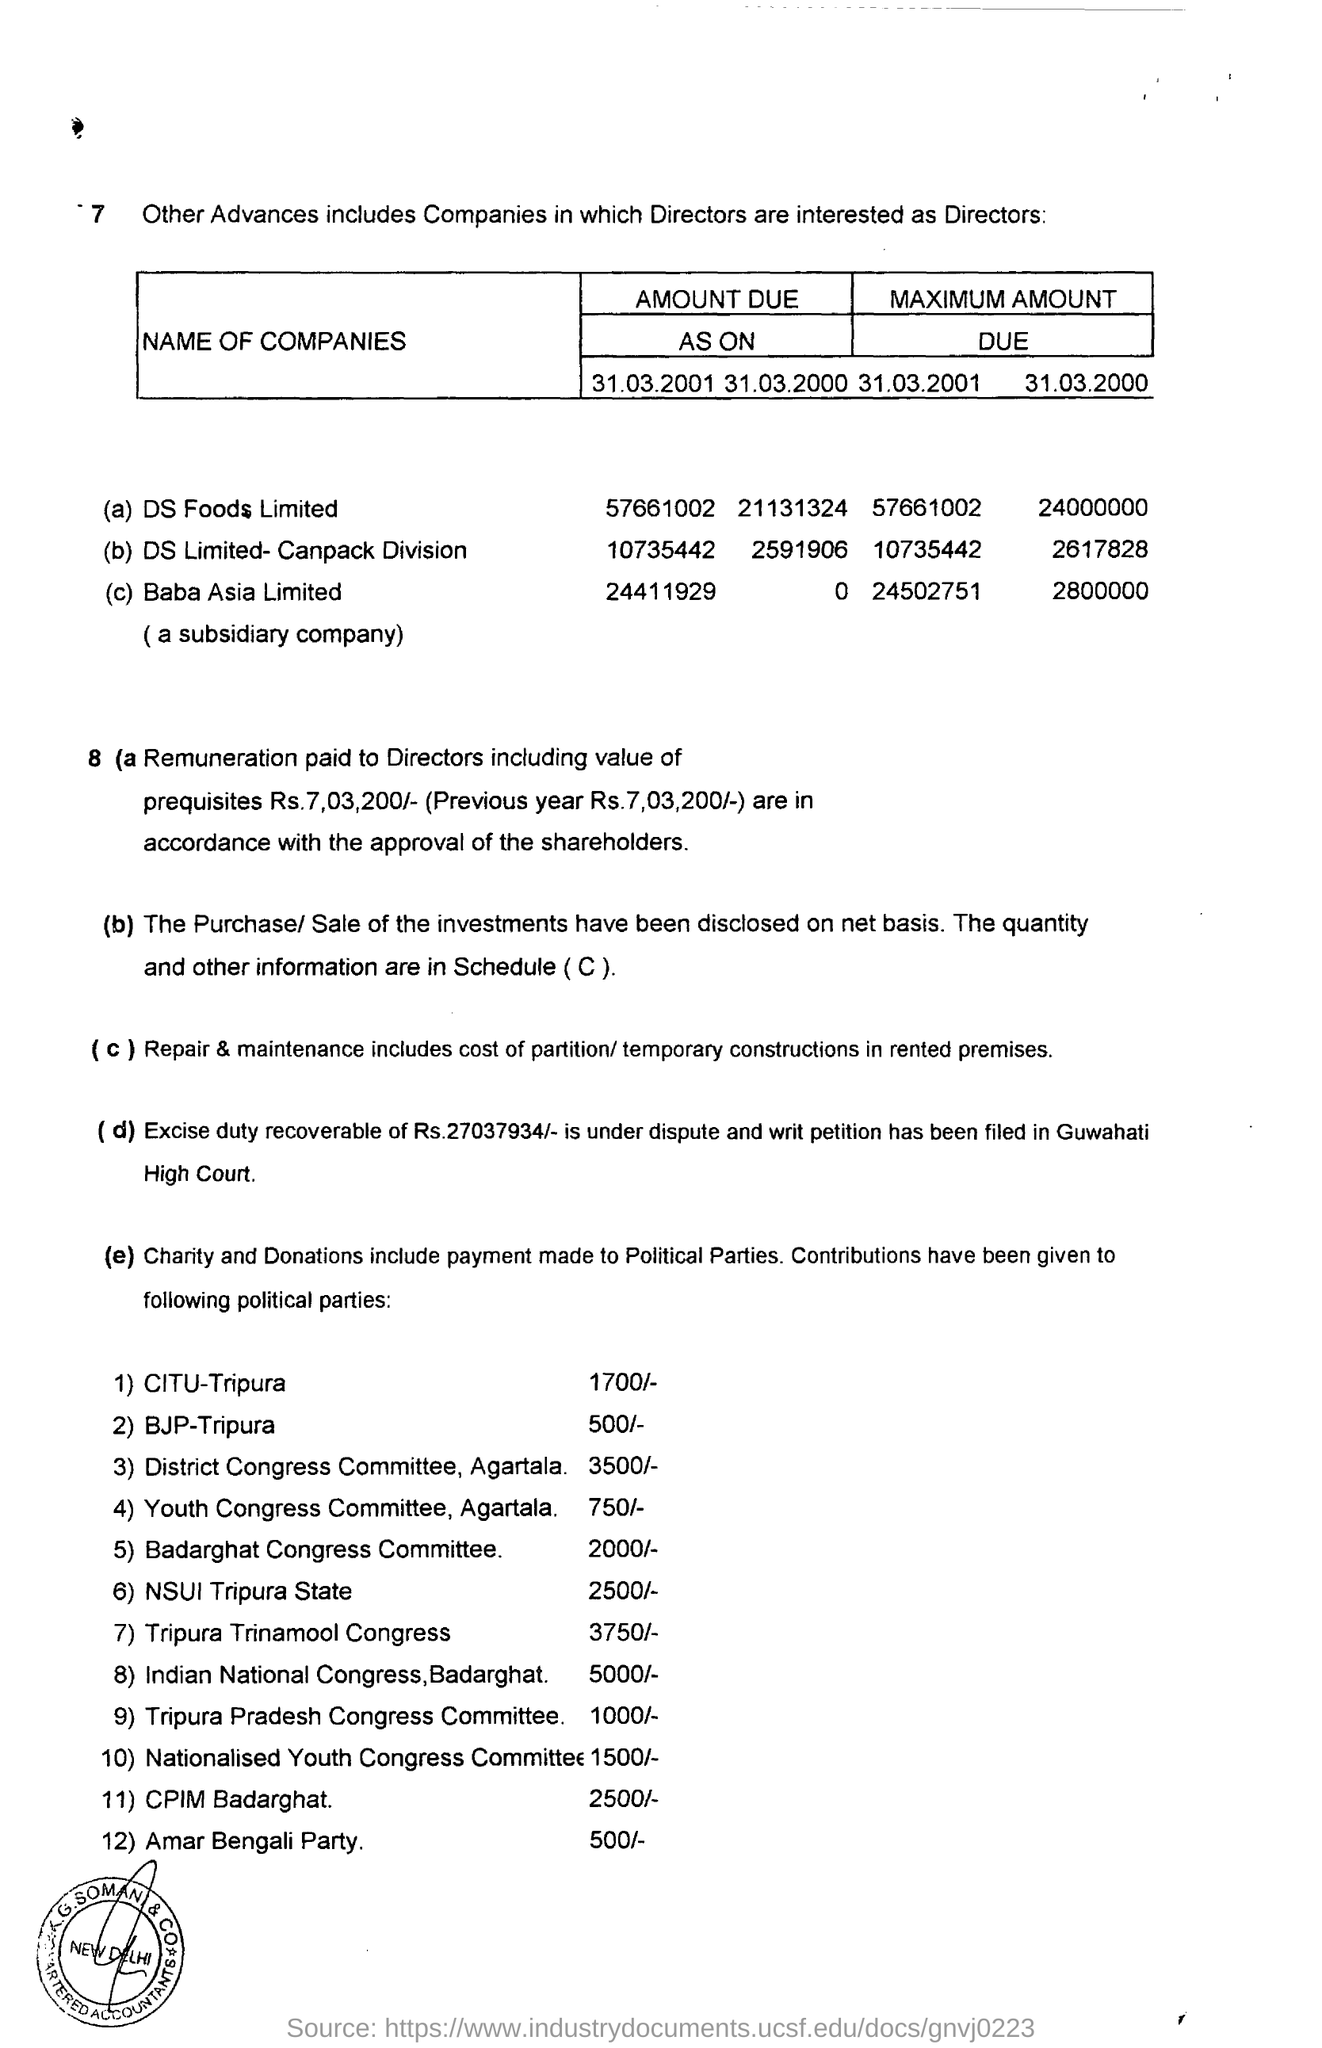List a handful of essential elements in this visual. The dispute and writ petition have been filed at the Guwahati High Court. The contribution to the BJP-Tripura is 500/-. The dispute and writ petition were filed for a claim of Rs.27,03,793/-. 